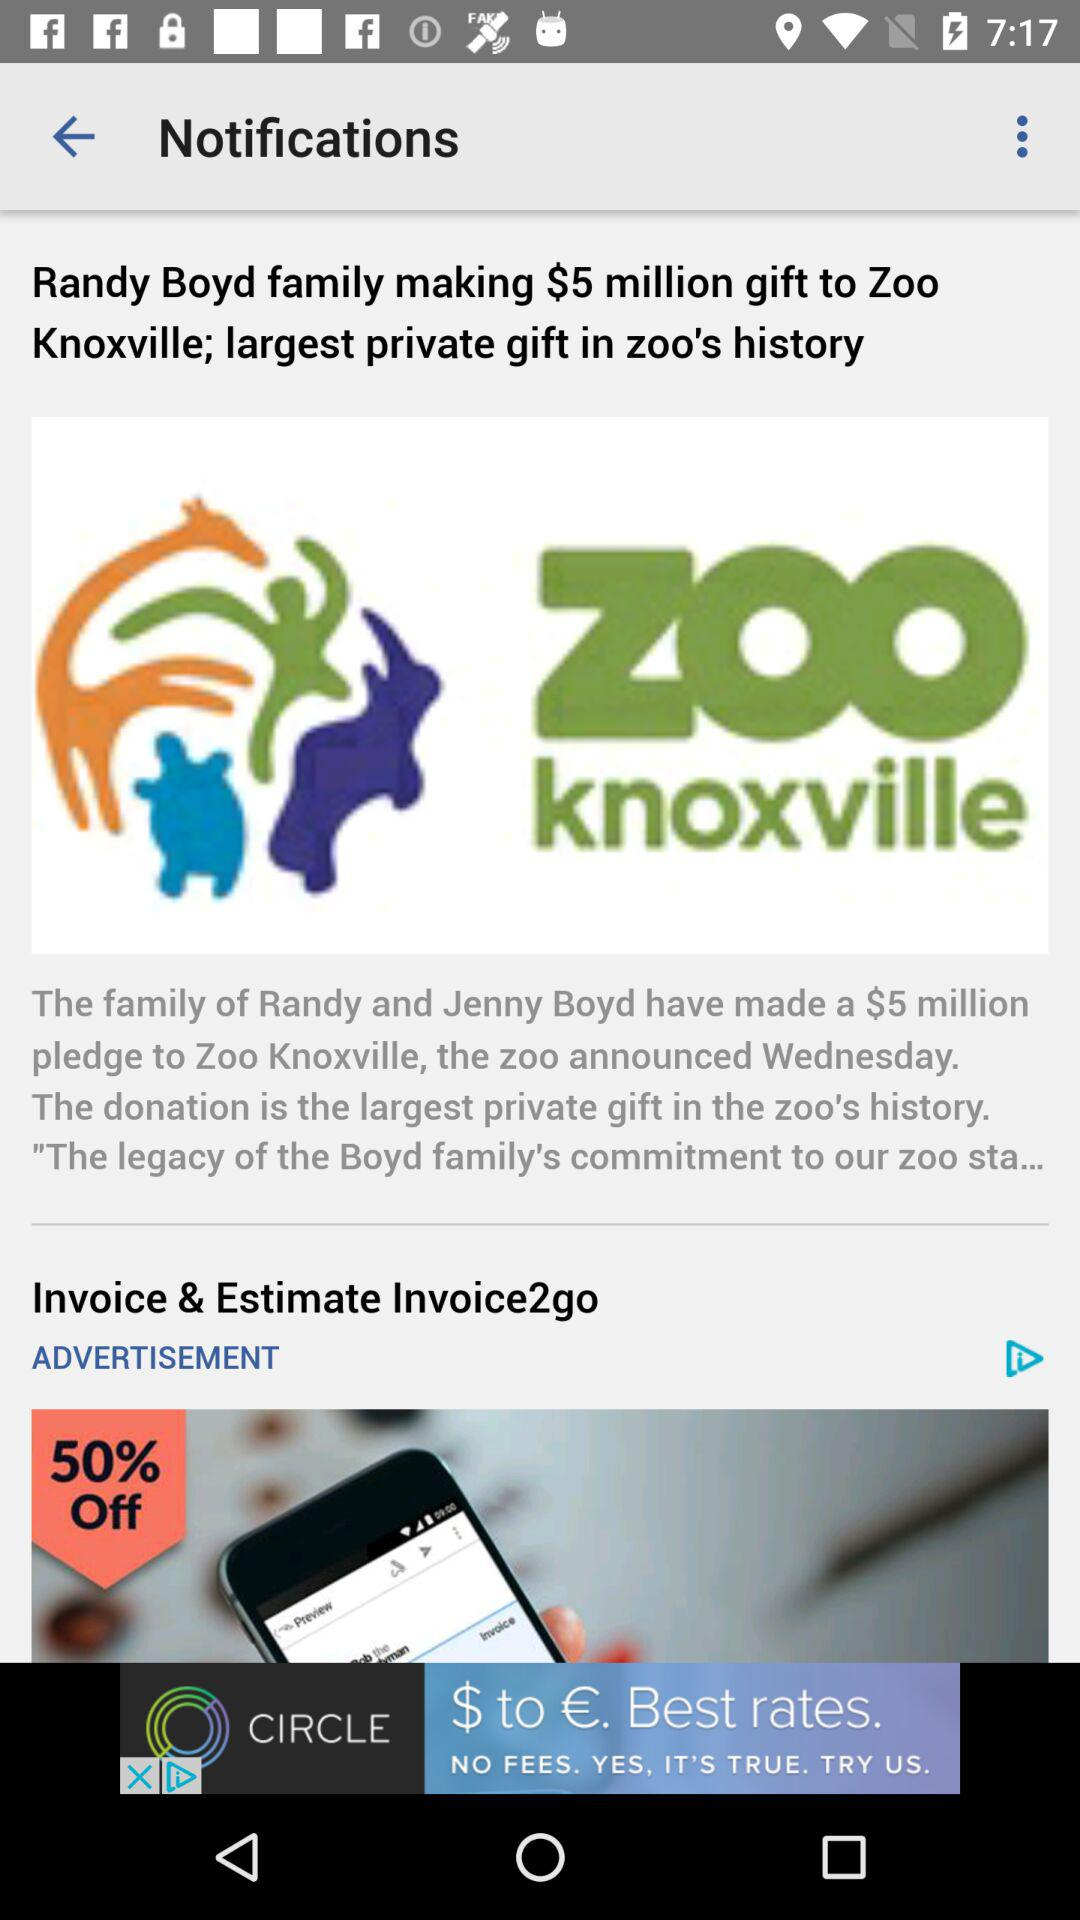How much did the Randy Boyd family gift to the zoo? The Randy Boyd family gifted $5 million to the zoo. 